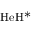<formula> <loc_0><loc_0><loc_500><loc_500>H e H ^ { * }</formula> 